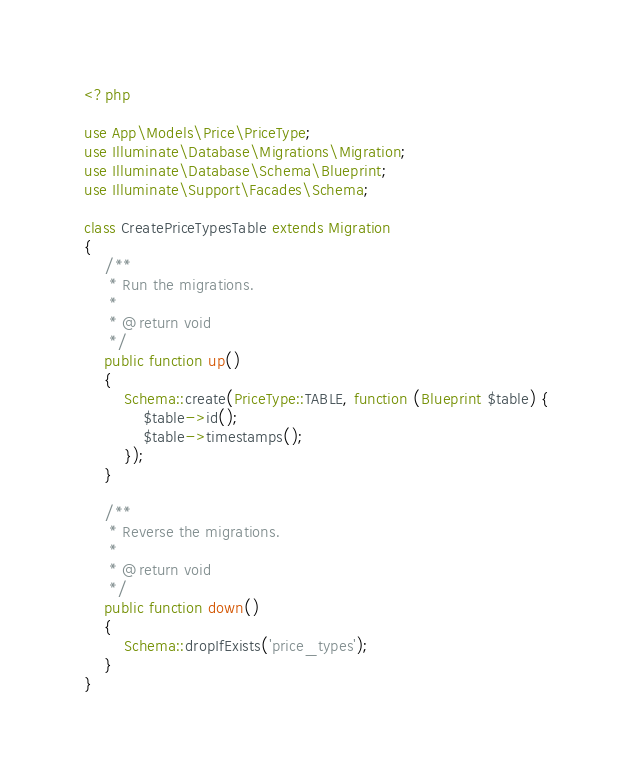Convert code to text. <code><loc_0><loc_0><loc_500><loc_500><_PHP_><?php

use App\Models\Price\PriceType;
use Illuminate\Database\Migrations\Migration;
use Illuminate\Database\Schema\Blueprint;
use Illuminate\Support\Facades\Schema;

class CreatePriceTypesTable extends Migration
{
    /**
     * Run the migrations.
     *
     * @return void
     */
    public function up()
    {
        Schema::create(PriceType::TABLE, function (Blueprint $table) {
            $table->id();
            $table->timestamps();
        });
    }

    /**
     * Reverse the migrations.
     *
     * @return void
     */
    public function down()
    {
        Schema::dropIfExists('price_types');
    }
}
</code> 